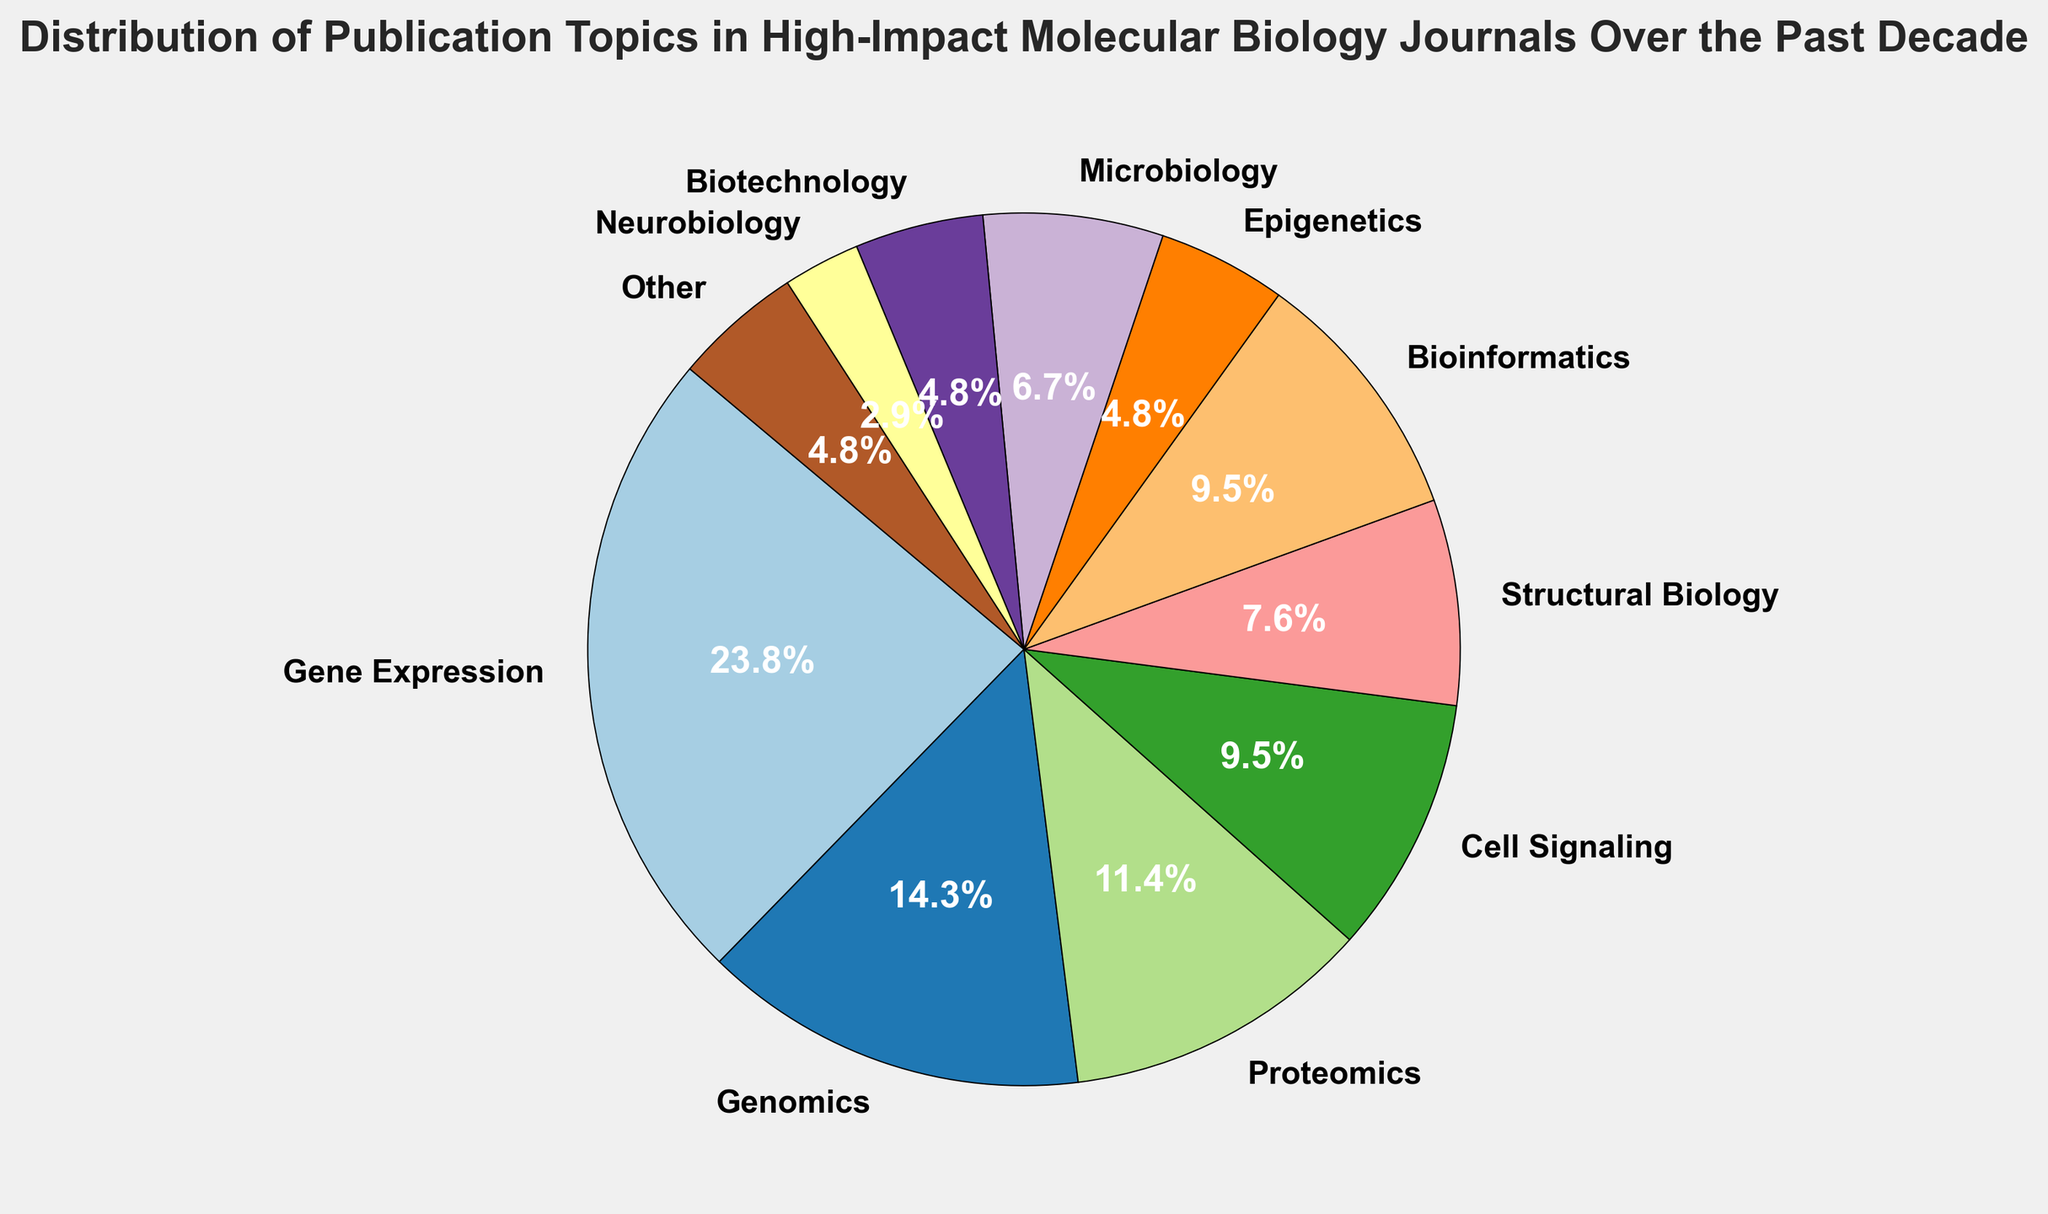Which category has the largest share of publication topics? The slice of the pie chart representing "Gene Expression" occupies the largest area, indicating it has the largest percentage.
Answer: Gene Expression How many categories have a share of 5% or less? The slices representing "Epigenetics", "Biotechnology", "Neurobiology", and "Other" each occupy 5% or less of the pie chart. Count the wedges for these categories.
Answer: 4 What is the combined percentage of "Genomics" and "Proteomics"? Add the percentages for "Genomics" and "Proteomics": 15% + 12%.
Answer: 27% Which category has a slightly larger share: "Cell Signaling" or "Bioinformatics"? Both slices should be compared visually, where "Cell Signaling" is represented with 10% and "Bioinformatics" also with 10%.
Answer: Equal When combined, do "Microbiology", "Biotechnology", and "Neurobiology" form a larger share than "Gene Expression"? Sum the percentages of "Microbiology" (7%), "Biotechnology" (5%), and "Neurobiology" (3%) which results in 15%. Compare this to "Gene Expression" at 25%.
Answer: No Which category has the smallest share? The slice representing "Neurobiology" appears the smallest, indicating it has the smallest percentage at just 3%.
Answer: Neurobiology If the topics "Genomics" and "Bioinformatics" are grouped together, what percentage of the total publications do they represent? Sum the percentages of "Genomics" and "Bioinformatics": 15% + 10%.
Answer: 25% Is "Structural Biology" more prevalent than "Microbiology"? Compare the sizes visually and look at the percentages: "Structural Biology" is 8%, and "Microbiology" is 7%.
Answer: Yes What is the sum of the percentages of all categories that have more than 10%? Sums include "Gene Expression" (25%) and "Genomics" (15%) and "Proteomics" (12%), resulting in 25% + 15% + 12%.
Answer: 52% Which three categories collectively account for about half of the total publication topics? Identify the categories "Gene Expression" (25%), "Genomics" (15%), and "Proteomics" (12%) and sum their percentages: 25% + 15% + 12%.
Answer: Gene Expression, Genomics, and Proteomics 